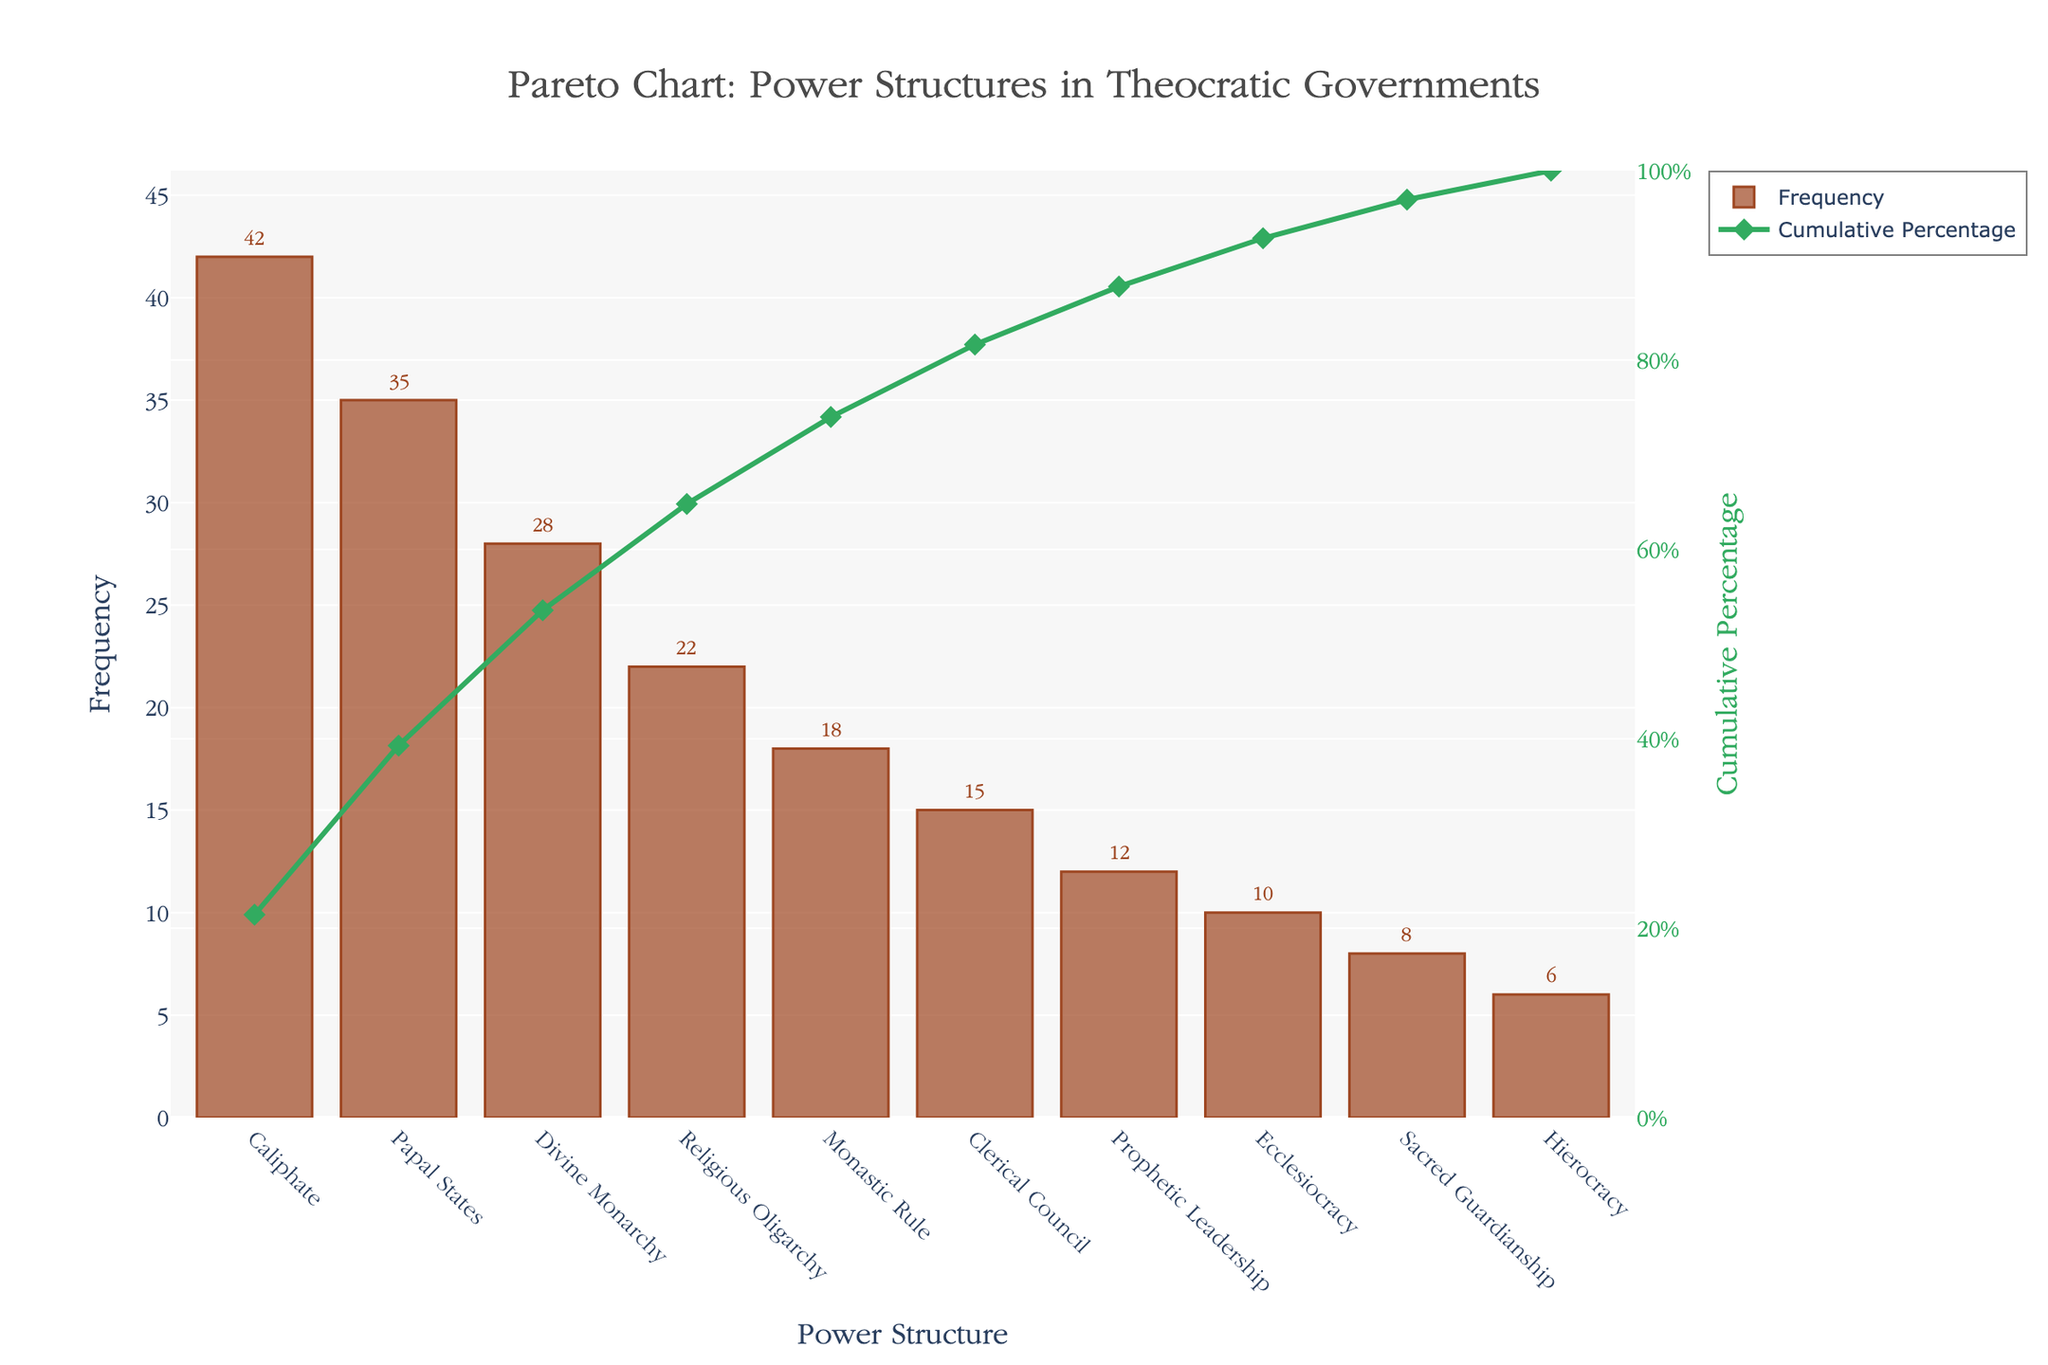What is the most common type of power structure in theocratic governments according to the figure? The most common type of power structure is the one with the highest bar on the chart, which is listed at the beginning.
Answer: Caliphate What is the cumulative percentage of the "Papal States" power structure? The cumulative percentage for each power structure can be found on the line chart. For the "Papal States," match it with the corresponding point on the line.
Answer: Approximately 29% Which power structure has the lowest frequency? The power structure with the lowest bar represents the lowest frequency.
Answer: Hierocracy What range does the y-axis (Frequency) cover? The y-axis range can be observed by looking at the lowest and highest values indicated on the axis.
Answer: 0 to around 46 What is the total frequency count for all power structures combined? Sum all the frequencies given for each power structure.
Answer: 196 How many power structures have a frequency of 20 or higher? Count the bars that reach 20 or more on the y-axis.
Answer: Four (Caliphate, Papal States, Divine Monarchy, Religious Oligarchy) Which power structures contribute to the first 50% of the cumulative percentage? Observe the cumulative percentage line and identify the power structures whose combined percentages reach around 50%.
Answer: Caliphate and Papal States Is the frequency of "Clerical Council" higher or lower than "Prophetic Leadership"? Compare the heights of the bars for these two power structures.
Answer: Higher What is the frequency difference between "Caliphate" and "Divine Monarchy"? Subtract the frequency of "Divine Monarchy" from that of "Caliphate."
Answer: 14 How many power structures have a cumulative percentage above 80%? Observe the cumulative percentage line and count the power structures that fall within the range above 80%.
Answer: Seven 